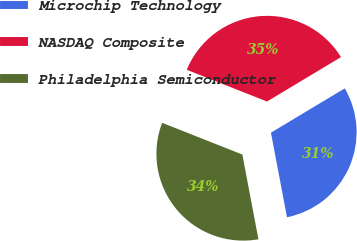Convert chart to OTSL. <chart><loc_0><loc_0><loc_500><loc_500><pie_chart><fcel>Microchip Technology<fcel>NASDAQ Composite<fcel>Philadelphia Semiconductor<nl><fcel>30.62%<fcel>35.4%<fcel>33.98%<nl></chart> 